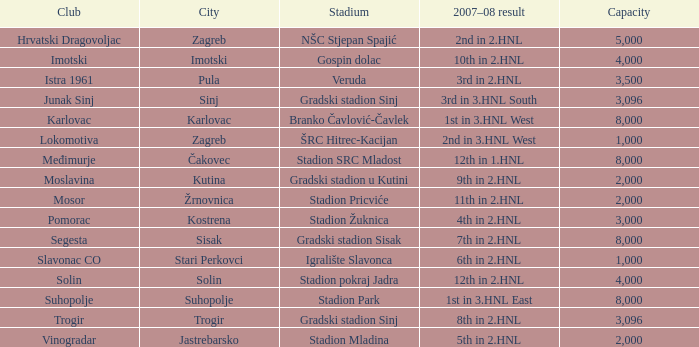What is the smallest seating capacity available at stadion mladina? 2000.0. 